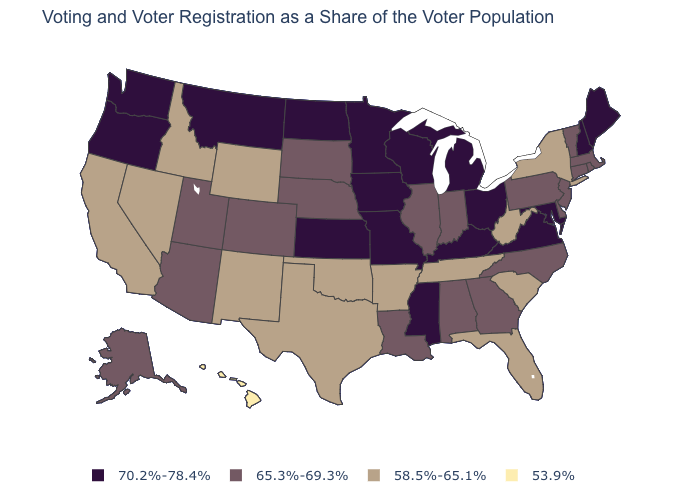Does Nebraska have the same value as Oklahoma?
Concise answer only. No. What is the value of Massachusetts?
Write a very short answer. 65.3%-69.3%. Does the first symbol in the legend represent the smallest category?
Quick response, please. No. Among the states that border New Hampshire , which have the highest value?
Short answer required. Maine. Does Michigan have the highest value in the USA?
Answer briefly. Yes. What is the value of Arkansas?
Keep it brief. 58.5%-65.1%. Name the states that have a value in the range 58.5%-65.1%?
Short answer required. Arkansas, California, Florida, Idaho, Nevada, New Mexico, New York, Oklahoma, South Carolina, Tennessee, Texas, West Virginia, Wyoming. What is the lowest value in the West?
Quick response, please. 53.9%. Does New Jersey have the lowest value in the USA?
Answer briefly. No. What is the value of Vermont?
Be succinct. 65.3%-69.3%. What is the value of Massachusetts?
Answer briefly. 65.3%-69.3%. Among the states that border Idaho , does Wyoming have the highest value?
Answer briefly. No. Which states hav the highest value in the West?
Be succinct. Montana, Oregon, Washington. What is the highest value in states that border Idaho?
Keep it brief. 70.2%-78.4%. What is the highest value in the USA?
Short answer required. 70.2%-78.4%. 